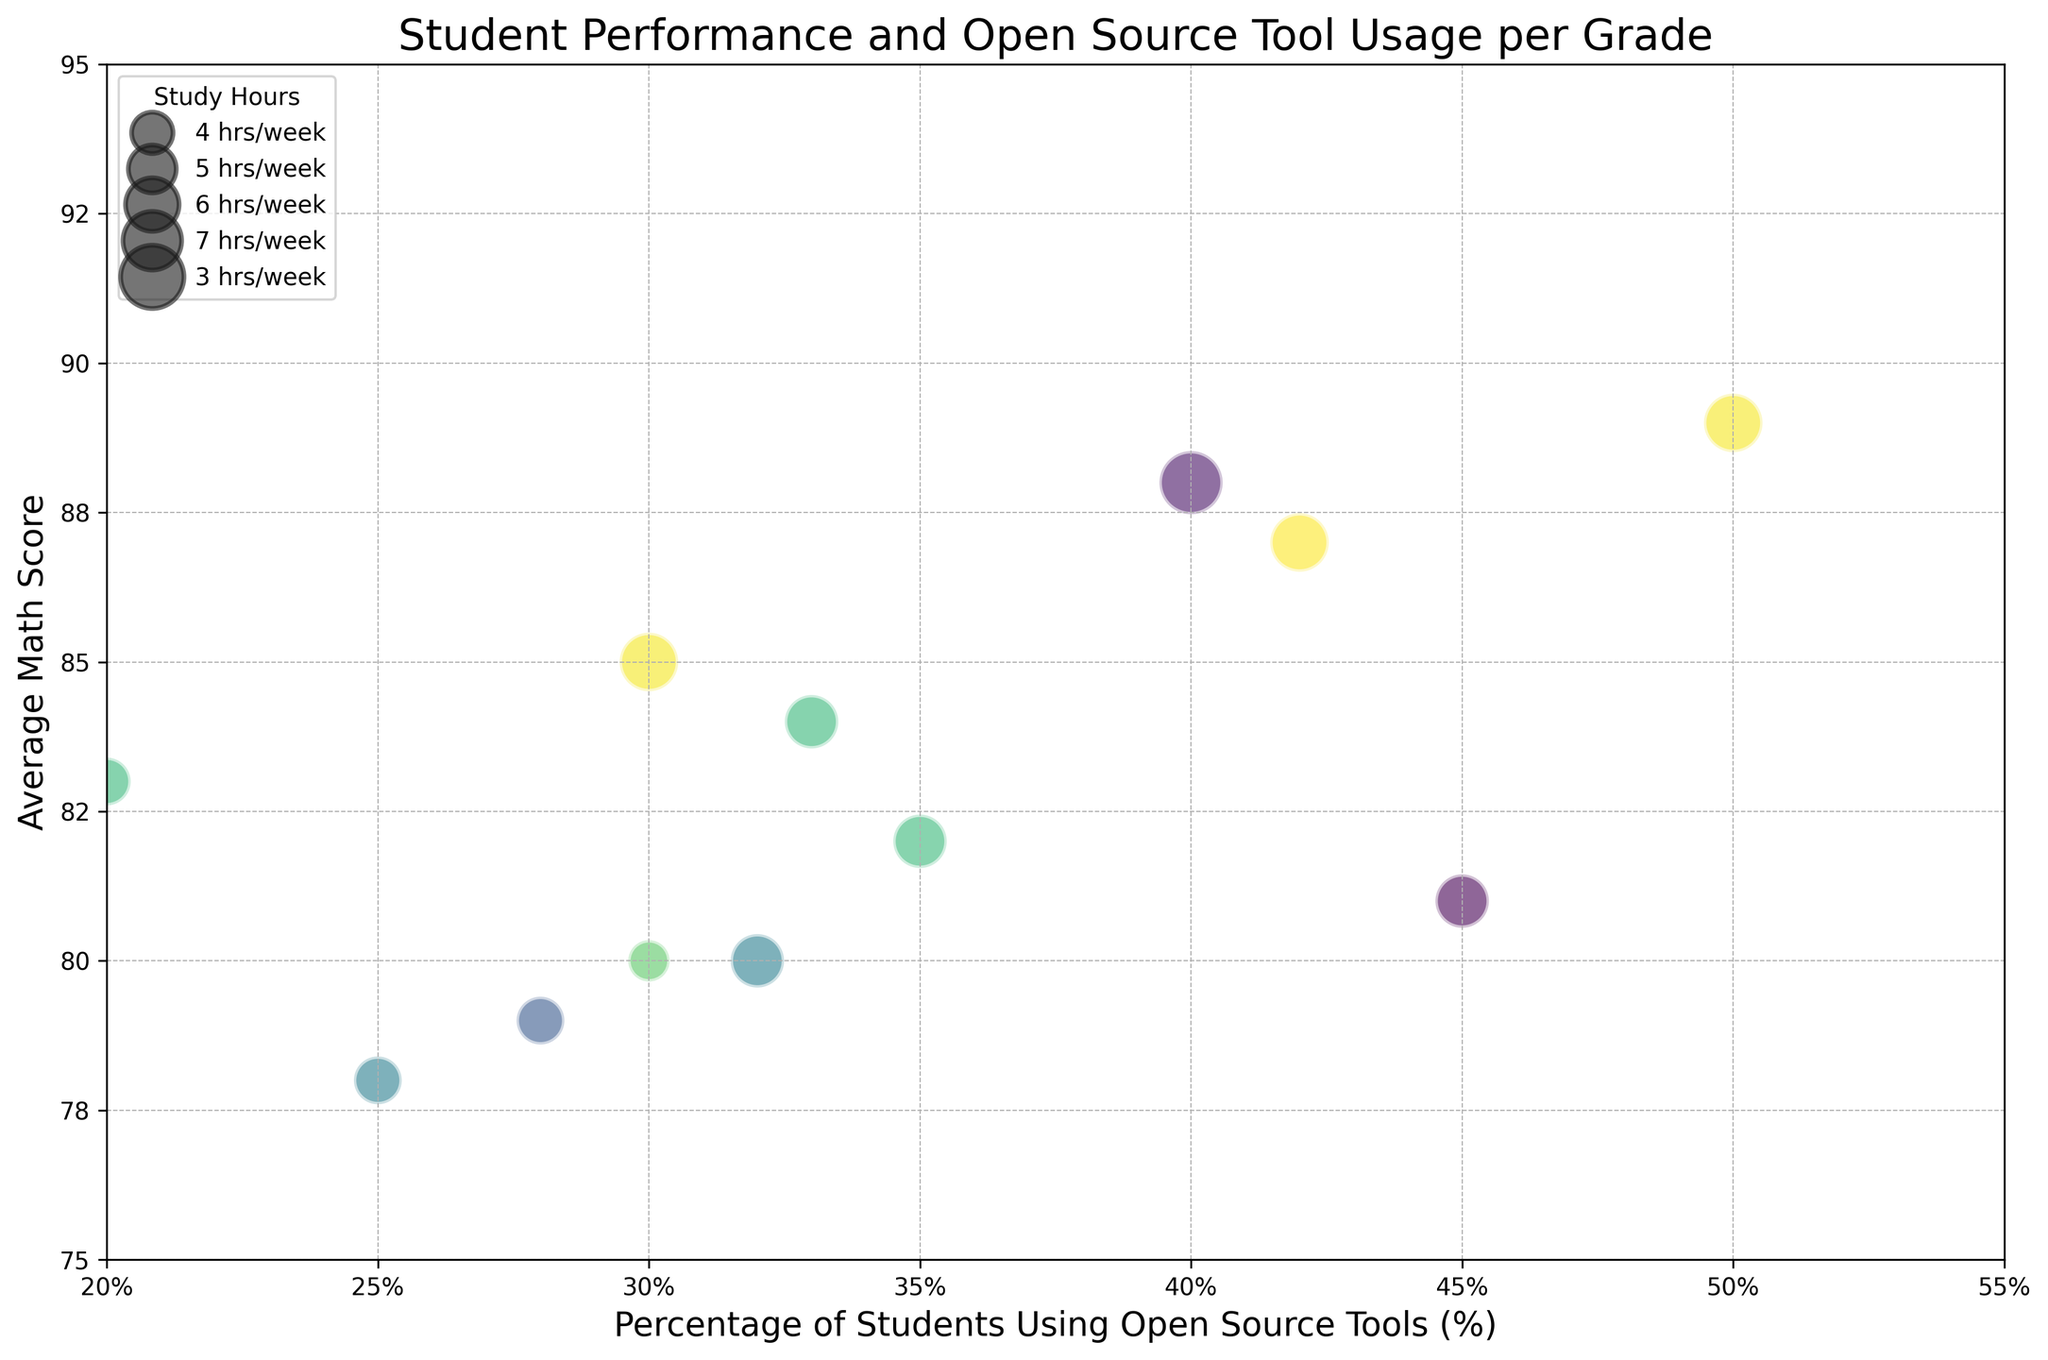What grade has the highest average math score? The highest average math score is represented by the uppermost bubble on the y-axis. For the average math score of 89, the bubbles correspond to grade 12. Thus, grade 12 has the highest average math score.
Answer: Grade 12 Which grade has the largest bubble and what does it represent? The largest bubble represents the grade with the highest study hours per week. The largest bubble is for grade 12 at the percentage of 50, which represents a study hours per week of 7.
Answer: Grade 12, 7 hours/week What is the total percentage of students using open source tools across all grades when the average math score is above 85? For average math scores above 85, the grades are 11 and 12. Summing the percentage of students for these grades: 30% (11th) + 40% (12th) + 33% (11th) + 42% (12th) + 50% (12th) = 195%.
Answer: 195% Comparing grades 9 and 10, which grade has a higher average usage percentage of open source tools and by how much? The average percentage of students using open source tools for grades 9 and 10 can be calculated as follows: 
Grade 9: (25% + 30% + 28%) / 3 = 27.67%
Grade 10: (35% + 45% + 32%) / 3 = 37.33%
Grade 10 has a higher average by 37.33% - 27.67% = 9.66%.
Answer: Grade 10, 9.66% Is there any correlation visually observable between the percentage of students using open source tools and their average math scores? Generally, the bubbles tend to move higher on the y-axis (math scores) as the percentage on the x-axis (students using open source tools) increases. This suggests a positive correlation between the percentage of students using open source tools and higher math scores.
Answer: Positive correlation Which grade has the smallest bubble and what is its corresponding average math score? The smallest bubble represents the lowest study hours per week. Here, the smallest bubble appears in grade 12 at the percentage of 40, representing an average math score of 88.
Answer: Grade 12, 88 Between grades 10 and 11, which has a higher average math score for the highest percentage of students using open source tools? For grade 10, the highest percentage of students using open source tools is 45%, with an average math score of 81. For grade 11, the highest is 33%, with an average math score of 84. Thus, grade 11 has a higher average math score.
Answer: Grade 11 If you were to rank the grades based on their maximum study hours per week, how would the ranking look? The ranking is based on the size of the bubbles, which corresponds to the study hours per week. Grade 12 has the highest study hours (7 hrs at 40%), followed by grade 11 (6 hrs at 30%), grade 10 (5 hrs at 35%), and grade 9 (4 hrs at 25%).
Answer: Grade 12, Grade 11, Grade 10, Grade 9 